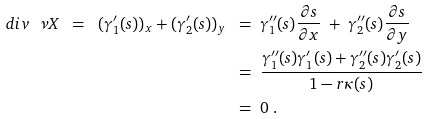Convert formula to latex. <formula><loc_0><loc_0><loc_500><loc_500>d i v \ \nu X \ = \ ( \gamma _ { 1 } ^ { \prime } ( s ) ) _ { x } + ( \gamma _ { 2 } ^ { \prime } ( s ) ) _ { y } \ & = \ \gamma _ { 1 } ^ { \prime \prime } ( s ) \frac { \partial s } { \partial x } \ + \ \gamma _ { 2 } ^ { \prime \prime } ( s ) \frac { \partial s } { \partial y } \\ & = \ \frac { \gamma _ { 1 } ^ { \prime \prime } ( s ) \gamma _ { 1 } ^ { \prime } ( s ) + \gamma _ { 2 } ^ { \prime \prime } ( s ) \gamma _ { 2 } ^ { \prime } ( s ) } { 1 - r \kappa ( s ) } \\ & = \ 0 \ .</formula> 